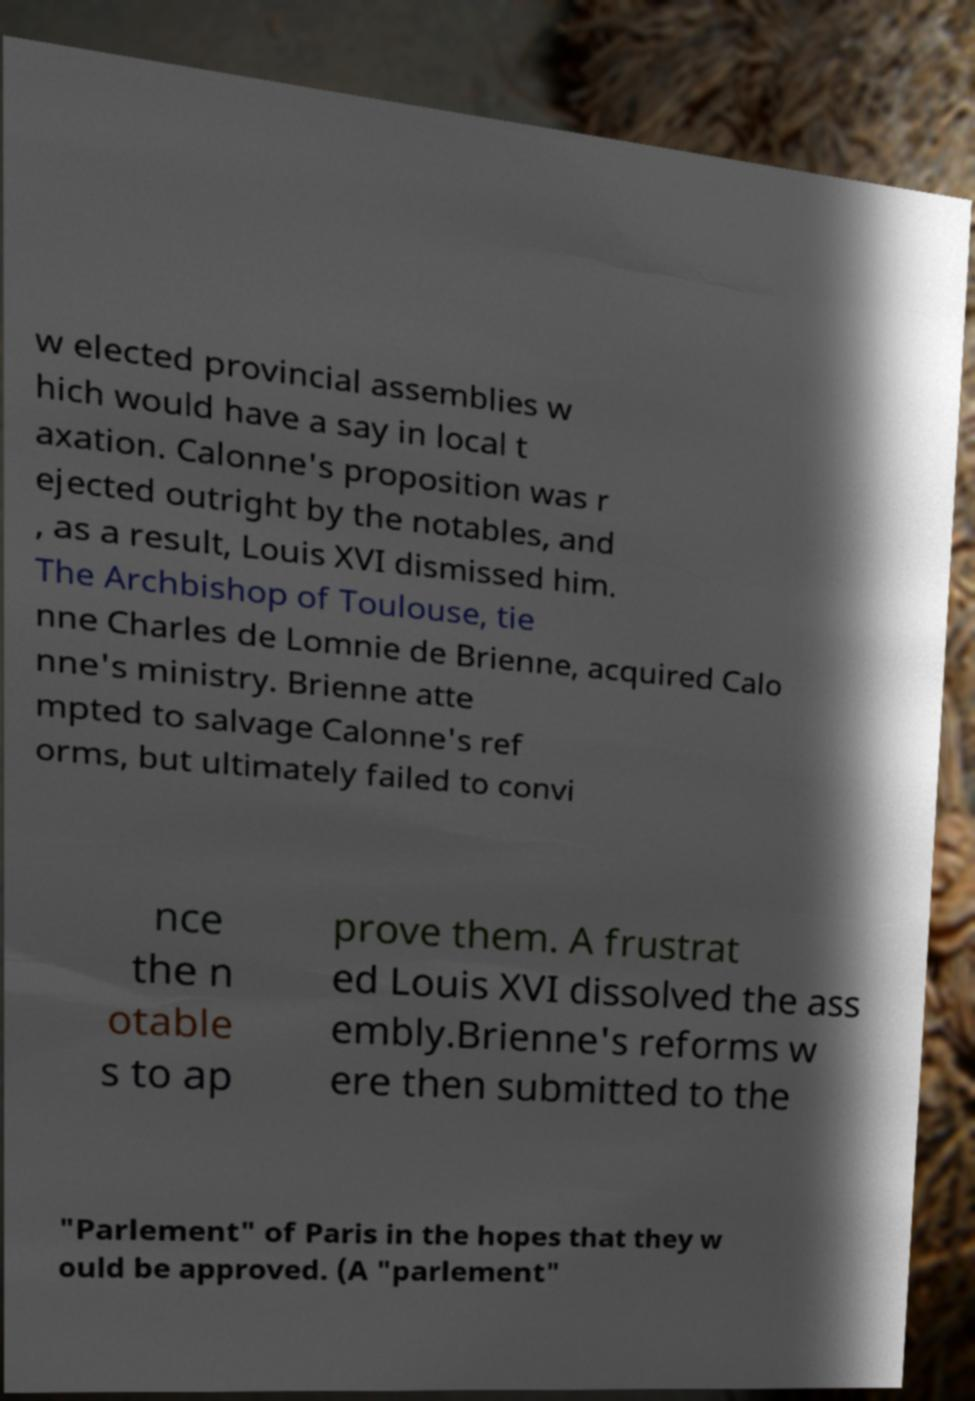Please read and relay the text visible in this image. What does it say? w elected provincial assemblies w hich would have a say in local t axation. Calonne's proposition was r ejected outright by the notables, and , as a result, Louis XVI dismissed him. The Archbishop of Toulouse, tie nne Charles de Lomnie de Brienne, acquired Calo nne's ministry. Brienne atte mpted to salvage Calonne's ref orms, but ultimately failed to convi nce the n otable s to ap prove them. A frustrat ed Louis XVI dissolved the ass embly.Brienne's reforms w ere then submitted to the "Parlement" of Paris in the hopes that they w ould be approved. (A "parlement" 